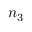<formula> <loc_0><loc_0><loc_500><loc_500>n _ { 3 }</formula> 